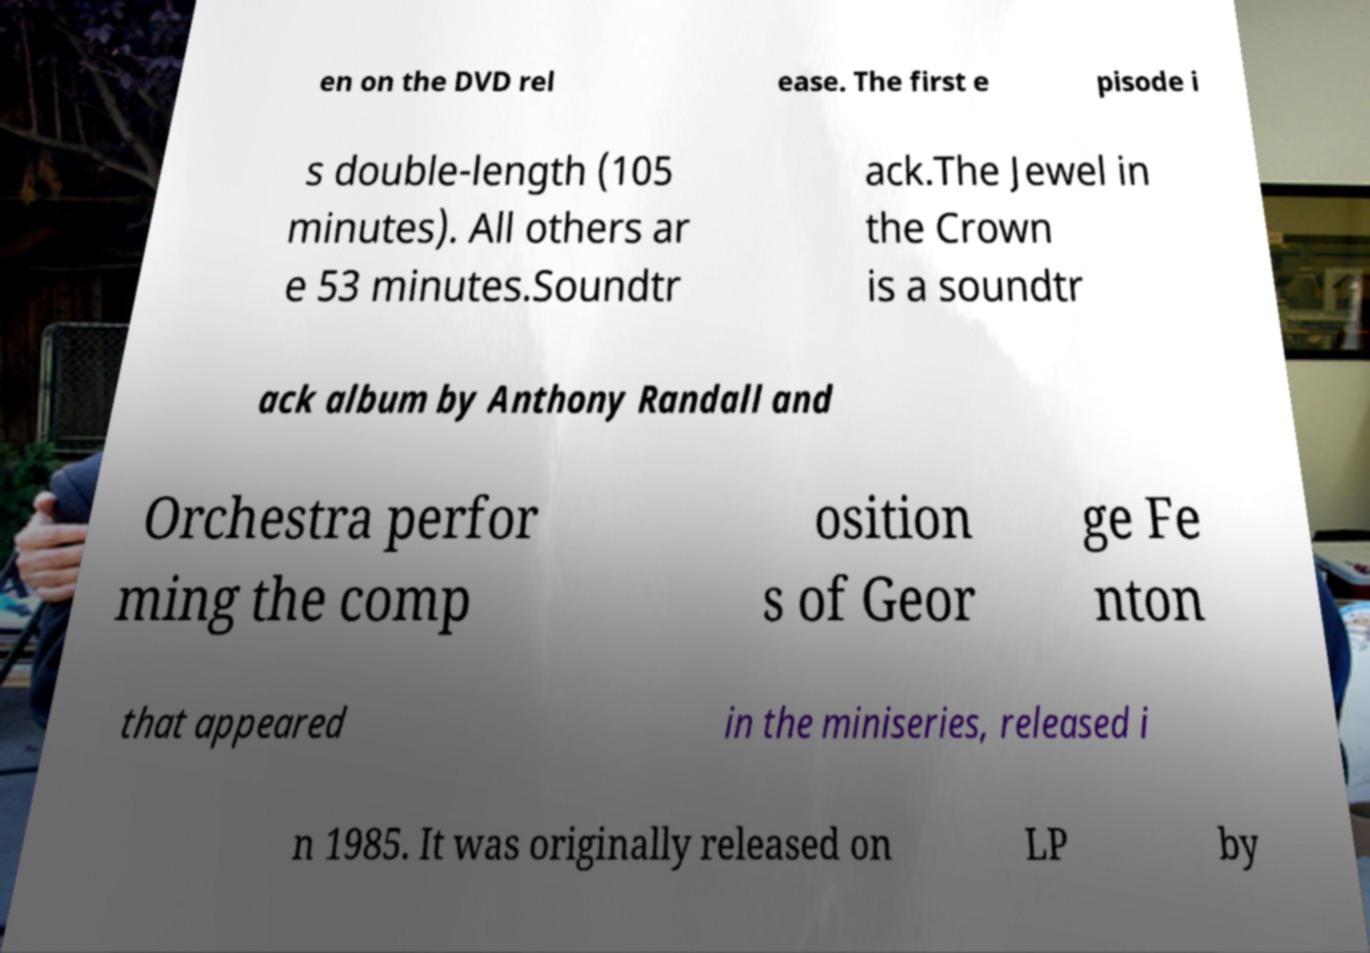What messages or text are displayed in this image? I need them in a readable, typed format. en on the DVD rel ease. The first e pisode i s double-length (105 minutes). All others ar e 53 minutes.Soundtr ack.The Jewel in the Crown is a soundtr ack album by Anthony Randall and Orchestra perfor ming the comp osition s of Geor ge Fe nton that appeared in the miniseries, released i n 1985. It was originally released on LP by 